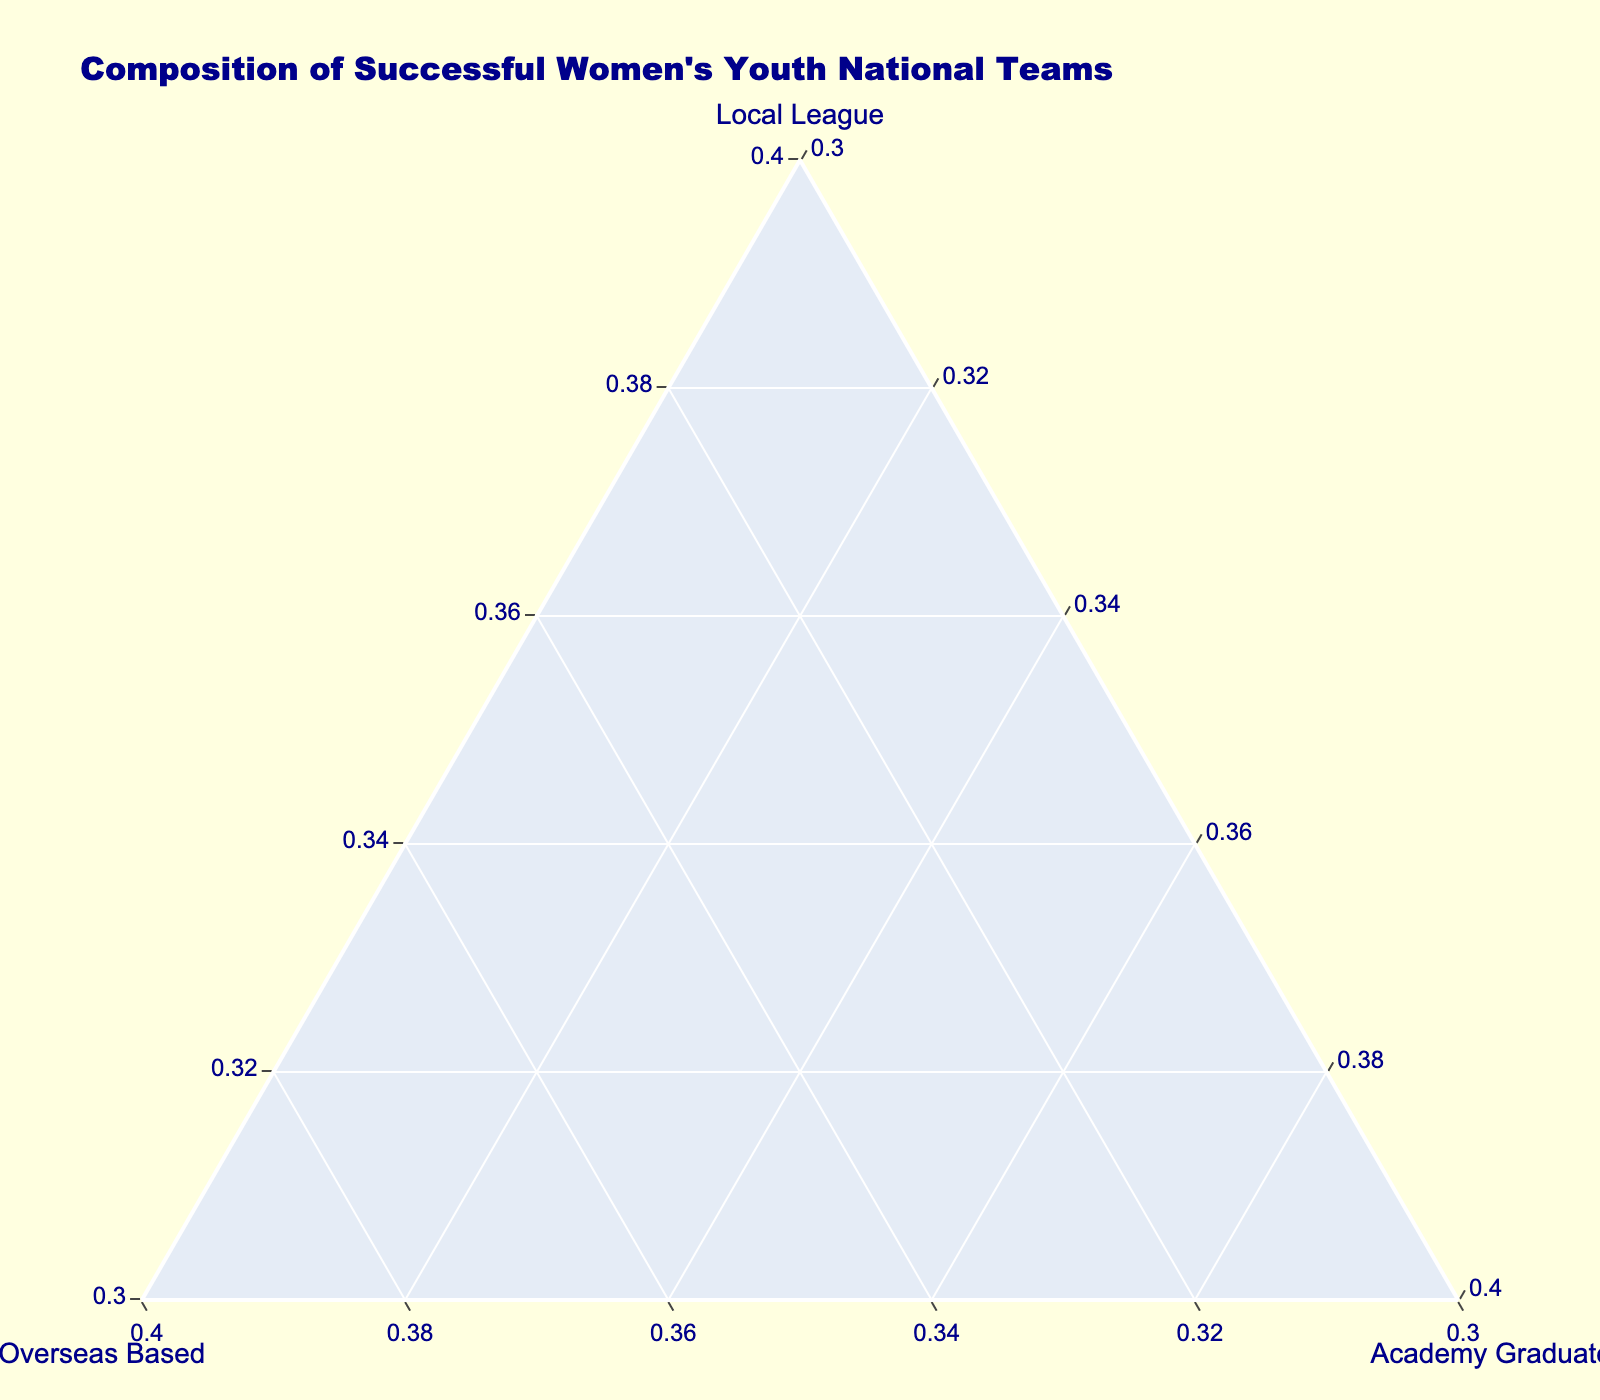Which team has the highest percentage of local league players? To find the highest percentage of local league players, look at the axis labeled 'Local League' and identify the data point farthest toward the 'Local League' corner. Japan U17 has the highest percentage with 80%.
Answer: Japan U17 Which team has the highest percentage of overseas-based players? To determine the team with the highest percentage of overseas-based players, look at the axis labeled 'Overseas Based' and identify the point closest to the 'Overseas Based' corner. Australia U19 has the highest percentage with 45%.
Answer: Australia U19 Which teams have more than 50% local league players? To find the teams with more than 50% local league players, check for data points that are closer to the 'Local League' axis and further from the halfway mark. England U20, Germany U19, France U18, Spain U19, Sweden U18, Japan U17, Denmark U20, Mexico U17, and Italy U19 all have more than 50% local league players.
Answer: England U20, Germany U19, France U18, Spain U19, Sweden U18, Japan U17, Denmark U20, Mexico U17, Italy U19 Which teams have the same percentage of academy graduates? To identify teams with the same percentage of academy graduates, look for data points on the same line parallel to the 'Academy Graduates' axis. Germany U19, Netherlands U20, Spain U19, Sweden U18, Canada U20, Norway U18, and Italy U19 all have 25% academy graduates.
Answer: Germany U19, Netherlands U20, Spain U19, Sweden U18, Canada U20, Norway U18, Italy U19 Which team has the most balanced composition of players across all three categories? To find the team with the most balanced composition, look for the data point closest to the center of the ternary plot. Italy U19 has relatively balanced percentages: 60% local league, 20% overseas-based, and 20% academy graduates.
Answer: Italy U19 What is the difference in the percentage of local league players between Canada U20 and Denmark U20? Calculate the difference by subtracting the percentage of local league players of Canada U20 (35%) from Denmark U20 (75%). The difference is 75% - 35% = 40%.
Answer: 40% Which team favors academy graduates the most? To determine which team favors academy graduates, look for the data point that is closest to the 'Academy Graduates' corner. USA U17 favors academy graduates the most with 50%.
Answer: USA U17 